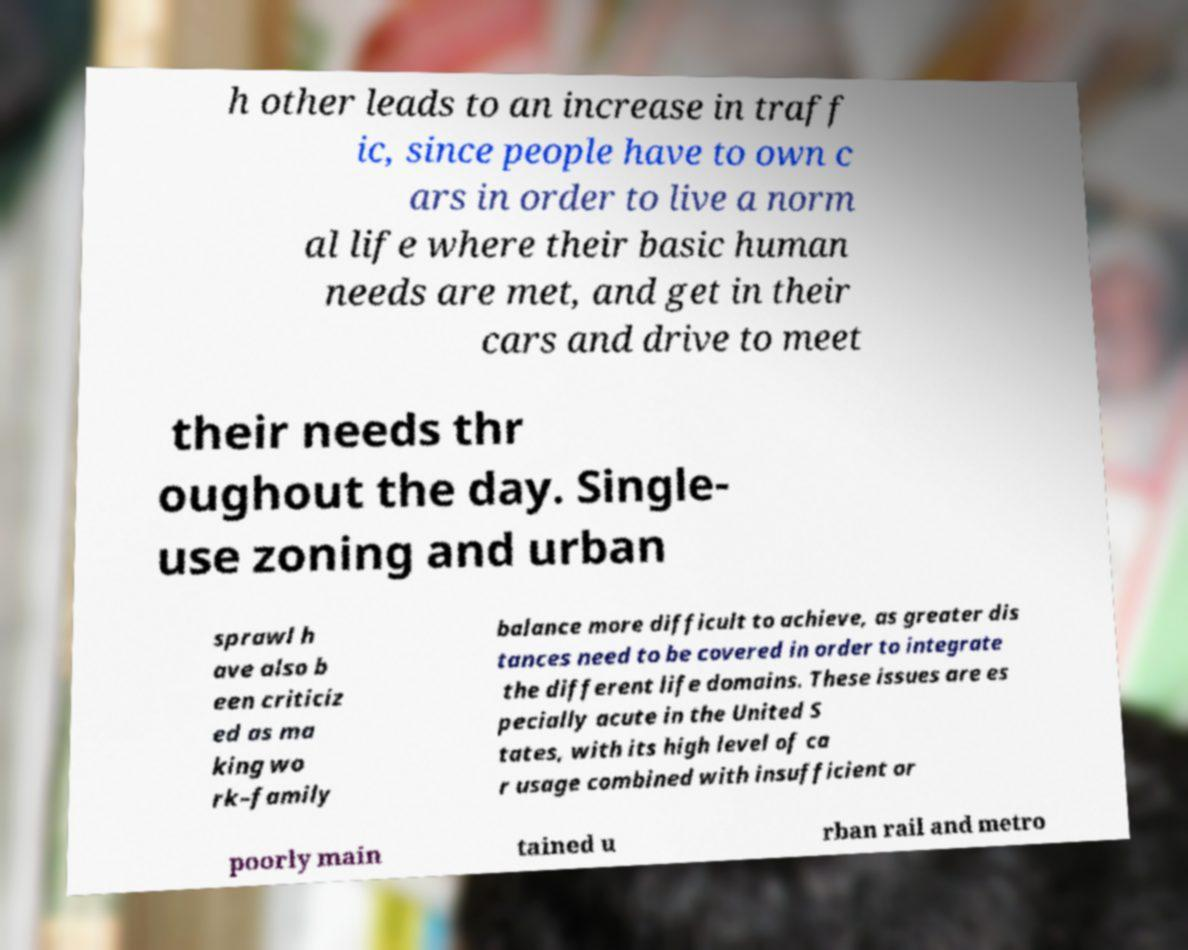What messages or text are displayed in this image? I need them in a readable, typed format. h other leads to an increase in traff ic, since people have to own c ars in order to live a norm al life where their basic human needs are met, and get in their cars and drive to meet their needs thr oughout the day. Single- use zoning and urban sprawl h ave also b een criticiz ed as ma king wo rk–family balance more difficult to achieve, as greater dis tances need to be covered in order to integrate the different life domains. These issues are es pecially acute in the United S tates, with its high level of ca r usage combined with insufficient or poorly main tained u rban rail and metro 